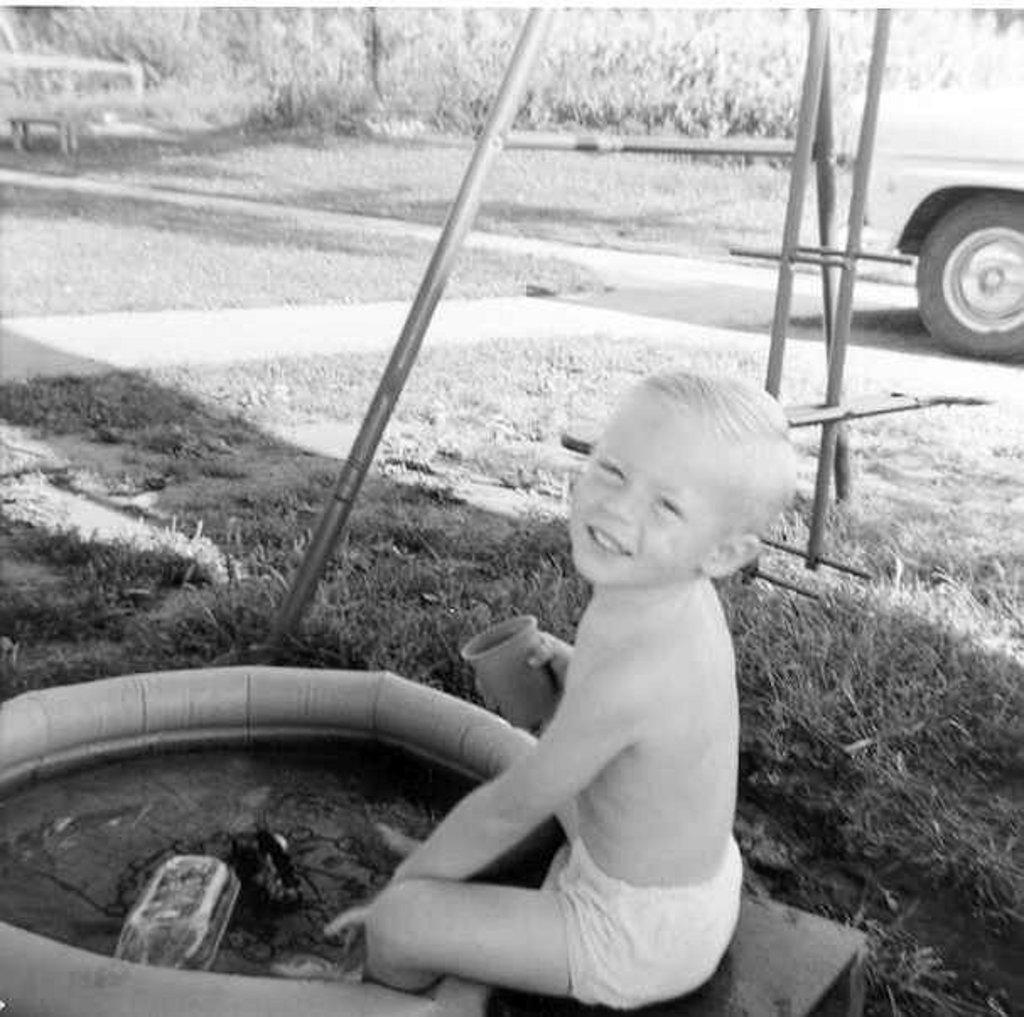How would you summarize this image in a sentence or two? This is a black and white picture, there is a boy sitting in the garden with a tube in front of him and behind him there is iron rod and truck, in the back there are plants. 